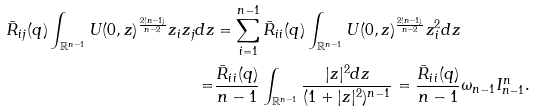Convert formula to latex. <formula><loc_0><loc_0><loc_500><loc_500>\bar { R } _ { i j } ( q ) \int _ { \mathbb { R } ^ { n - 1 } } U ( 0 , z ) ^ { \frac { 2 ( n - 1 ) } { n - 2 } } z _ { i } z _ { j } d z & = \sum _ { i = 1 } ^ { n - 1 } \bar { R } _ { i i } ( q ) \int _ { \mathbb { R } ^ { n - 1 } } U ( 0 , z ) ^ { \frac { 2 ( n - 1 ) } { n - 2 } } z _ { i } ^ { 2 } d z \\ = & \frac { \bar { R } _ { i i } ( q ) } { n - 1 } \int _ { \mathbb { R } ^ { n - 1 } } \frac { | z | ^ { 2 } d z } { ( 1 + | z | ^ { 2 } ) ^ { n - 1 } } = \frac { \bar { R } _ { i i } ( q ) } { n - 1 } \omega _ { n - 1 } I _ { n - 1 } ^ { n } .</formula> 